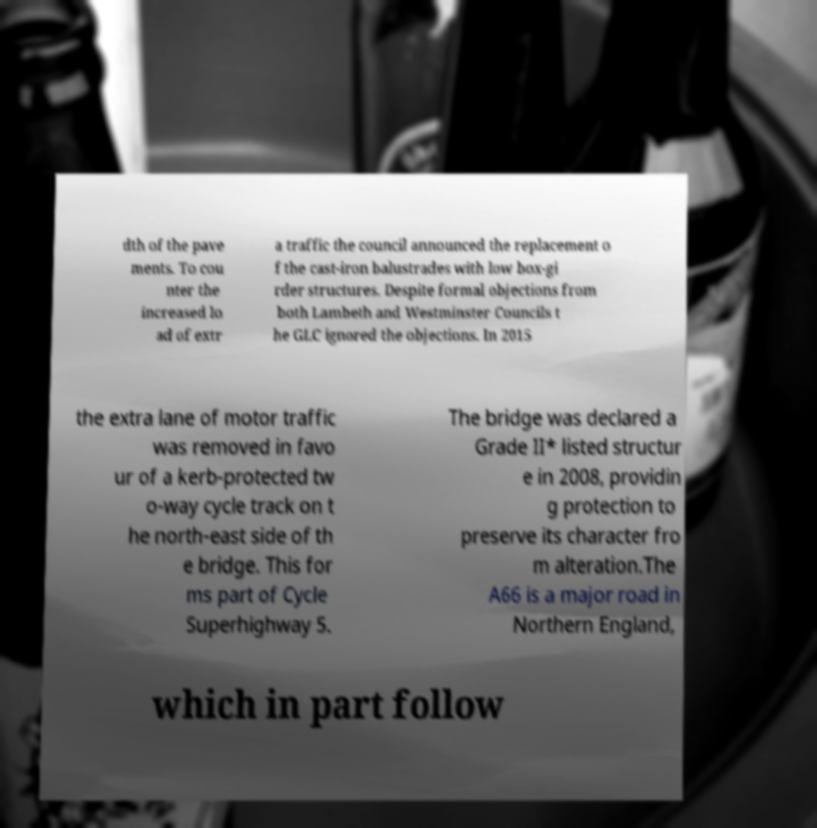Please read and relay the text visible in this image. What does it say? dth of the pave ments. To cou nter the increased lo ad of extr a traffic the council announced the replacement o f the cast-iron balustrades with low box-gi rder structures. Despite formal objections from both Lambeth and Westminster Councils t he GLC ignored the objections. In 2015 the extra lane of motor traffic was removed in favo ur of a kerb-protected tw o-way cycle track on t he north-east side of th e bridge. This for ms part of Cycle Superhighway 5. The bridge was declared a Grade II* listed structur e in 2008, providin g protection to preserve its character fro m alteration.The A66 is a major road in Northern England, which in part follow 